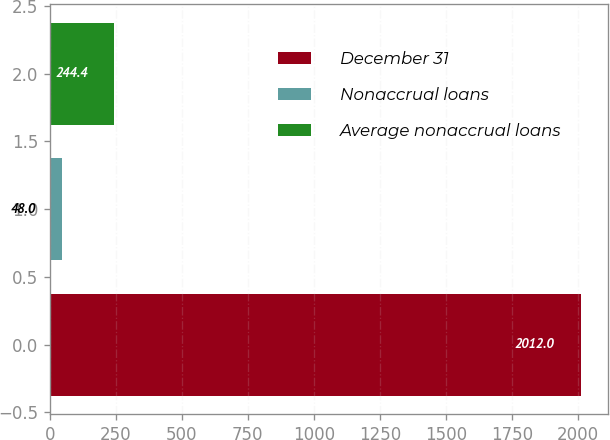Convert chart to OTSL. <chart><loc_0><loc_0><loc_500><loc_500><bar_chart><fcel>December 31<fcel>Nonaccrual loans<fcel>Average nonaccrual loans<nl><fcel>2012<fcel>48<fcel>244.4<nl></chart> 